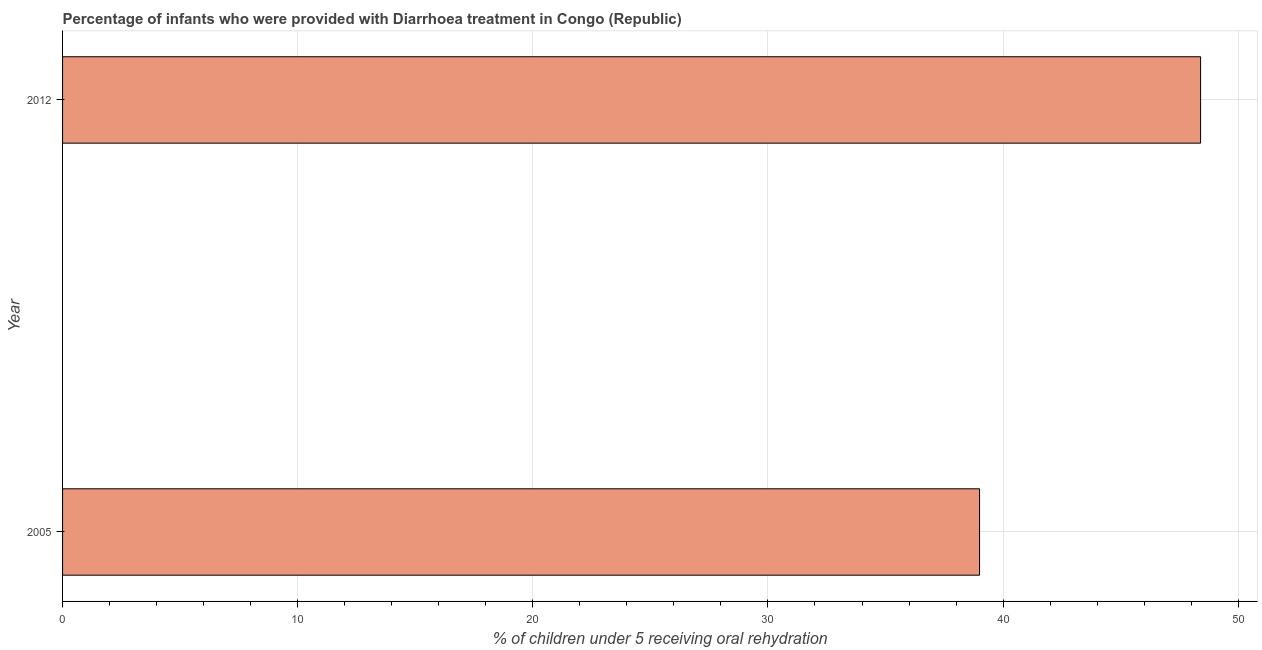Does the graph contain grids?
Offer a very short reply. Yes. What is the title of the graph?
Provide a short and direct response. Percentage of infants who were provided with Diarrhoea treatment in Congo (Republic). What is the label or title of the X-axis?
Your answer should be very brief. % of children under 5 receiving oral rehydration. What is the percentage of children who were provided with treatment diarrhoea in 2005?
Provide a short and direct response. 39. Across all years, what is the maximum percentage of children who were provided with treatment diarrhoea?
Offer a very short reply. 48.4. Across all years, what is the minimum percentage of children who were provided with treatment diarrhoea?
Provide a short and direct response. 39. In which year was the percentage of children who were provided with treatment diarrhoea maximum?
Make the answer very short. 2012. What is the sum of the percentage of children who were provided with treatment diarrhoea?
Offer a terse response. 87.4. What is the average percentage of children who were provided with treatment diarrhoea per year?
Make the answer very short. 43.7. What is the median percentage of children who were provided with treatment diarrhoea?
Keep it short and to the point. 43.7. Do a majority of the years between 2005 and 2012 (inclusive) have percentage of children who were provided with treatment diarrhoea greater than 46 %?
Provide a succinct answer. No. What is the ratio of the percentage of children who were provided with treatment diarrhoea in 2005 to that in 2012?
Provide a short and direct response. 0.81. Is the percentage of children who were provided with treatment diarrhoea in 2005 less than that in 2012?
Ensure brevity in your answer.  Yes. How many bars are there?
Your answer should be compact. 2. Are all the bars in the graph horizontal?
Your response must be concise. Yes. How many years are there in the graph?
Your answer should be very brief. 2. Are the values on the major ticks of X-axis written in scientific E-notation?
Provide a short and direct response. No. What is the % of children under 5 receiving oral rehydration in 2012?
Make the answer very short. 48.4. What is the ratio of the % of children under 5 receiving oral rehydration in 2005 to that in 2012?
Give a very brief answer. 0.81. 